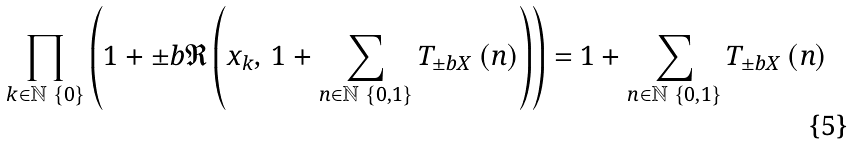Convert formula to latex. <formula><loc_0><loc_0><loc_500><loc_500>\prod _ { k \in \mathbb { N } \ \left \{ 0 \right \} } \left ( 1 + \pm b { \mathfrak { R } } \left ( x _ { k } , \, 1 + \sum _ { n \in \mathbb { N } \ \left \{ 0 , 1 \right \} } T _ { \pm b { X } } \left ( n \right ) \right ) \right ) = 1 + \sum _ { n \in \mathbb { N } \ \left \{ 0 , 1 \right \} } T _ { \pm b { X } } \left ( n \right )</formula> 